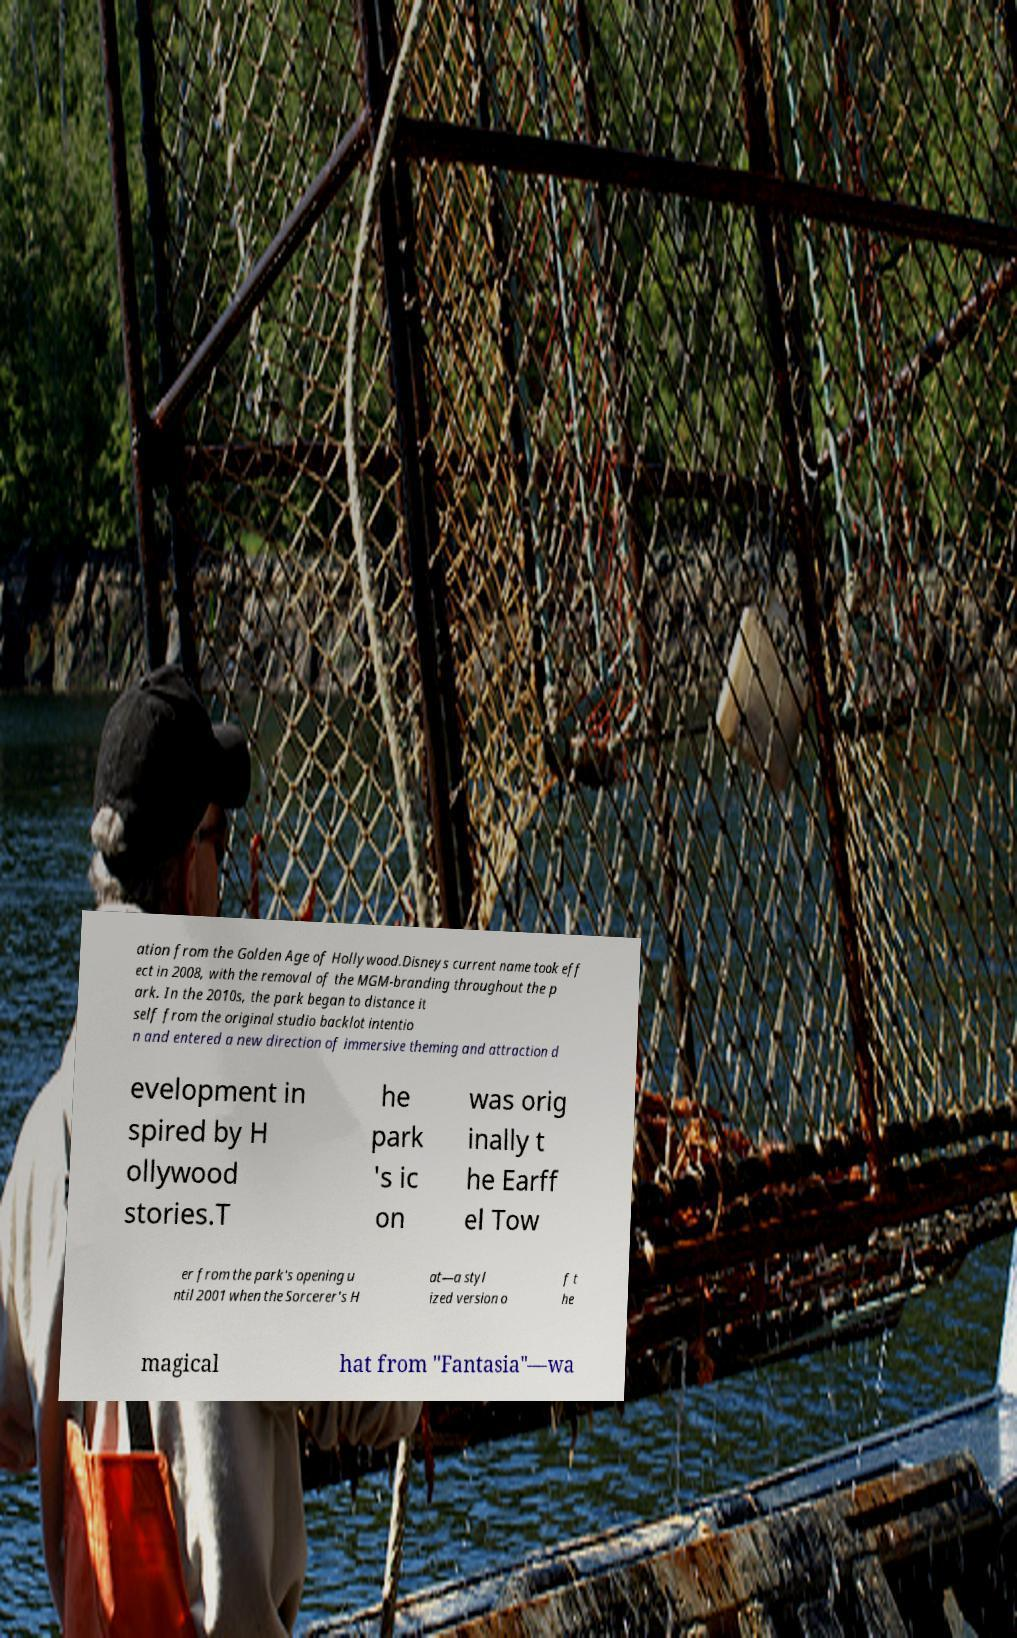There's text embedded in this image that I need extracted. Can you transcribe it verbatim? ation from the Golden Age of Hollywood.Disneys current name took eff ect in 2008, with the removal of the MGM-branding throughout the p ark. In the 2010s, the park began to distance it self from the original studio backlot intentio n and entered a new direction of immersive theming and attraction d evelopment in spired by H ollywood stories.T he park 's ic on was orig inally t he Earff el Tow er from the park's opening u ntil 2001 when the Sorcerer's H at—a styl ized version o f t he magical hat from "Fantasia"—wa 